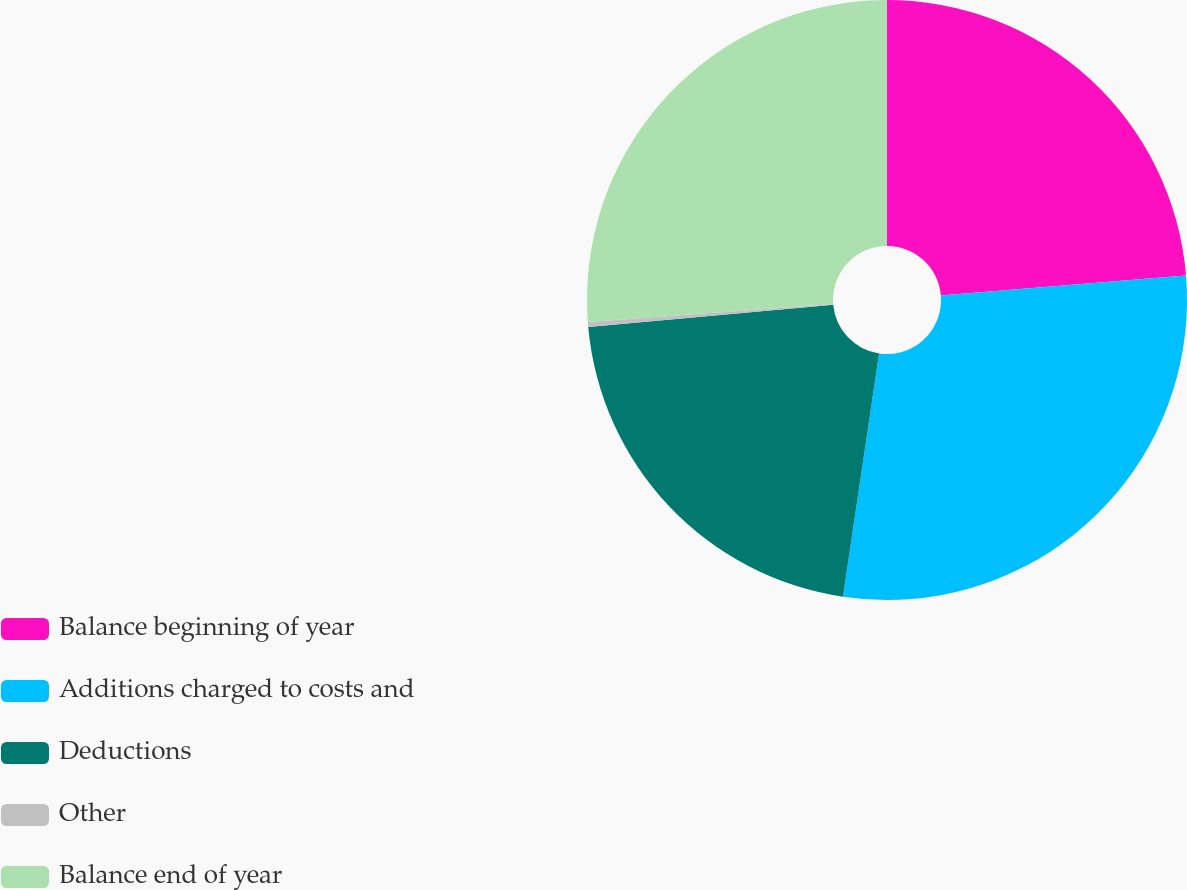<chart> <loc_0><loc_0><loc_500><loc_500><pie_chart><fcel>Balance beginning of year<fcel>Additions charged to costs and<fcel>Deductions<fcel>Other<fcel>Balance end of year<nl><fcel>23.7%<fcel>28.65%<fcel>21.22%<fcel>0.27%<fcel>26.17%<nl></chart> 